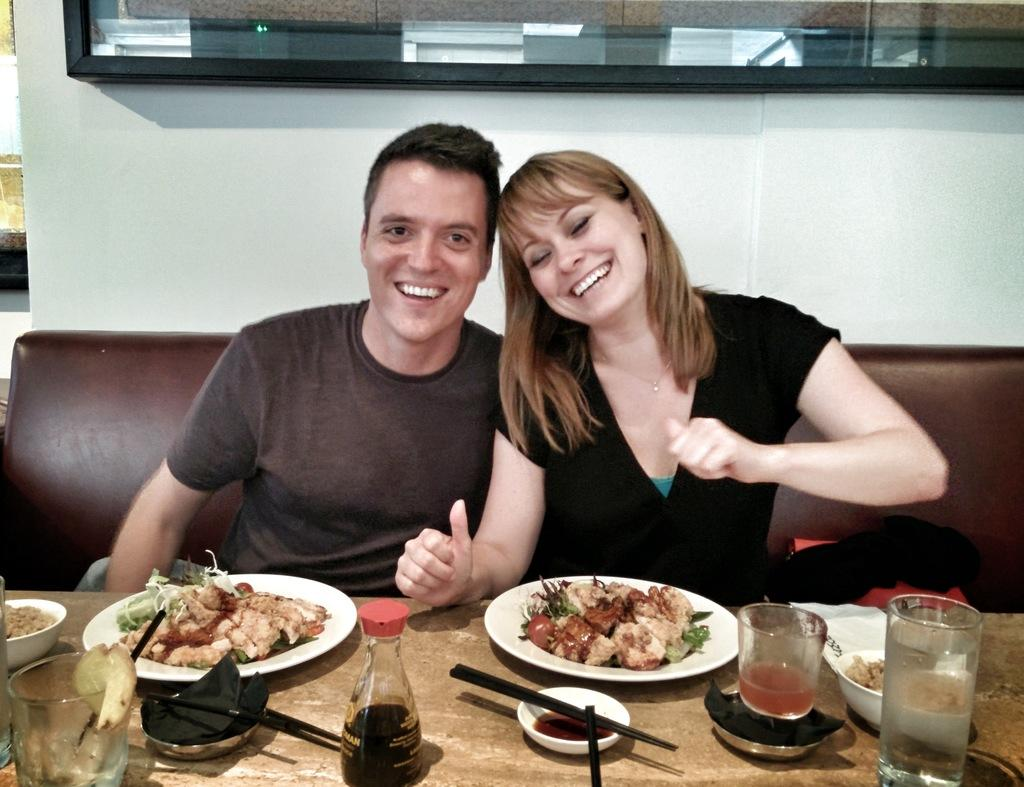What are the people in the image doing? There is a couple sitting on the sofa in the image. What objects can be seen on the table in the image? There is a glass, a plate, a bottle, and food items on the table in the image. What is the background of the image? There is a wall visible in the image. What type of fly can be seen buzzing around the couple in the image? There is no fly present in the image. What is the voice of the couple discussing in the image? The image does not provide any information about the couple's conversation or voices. 